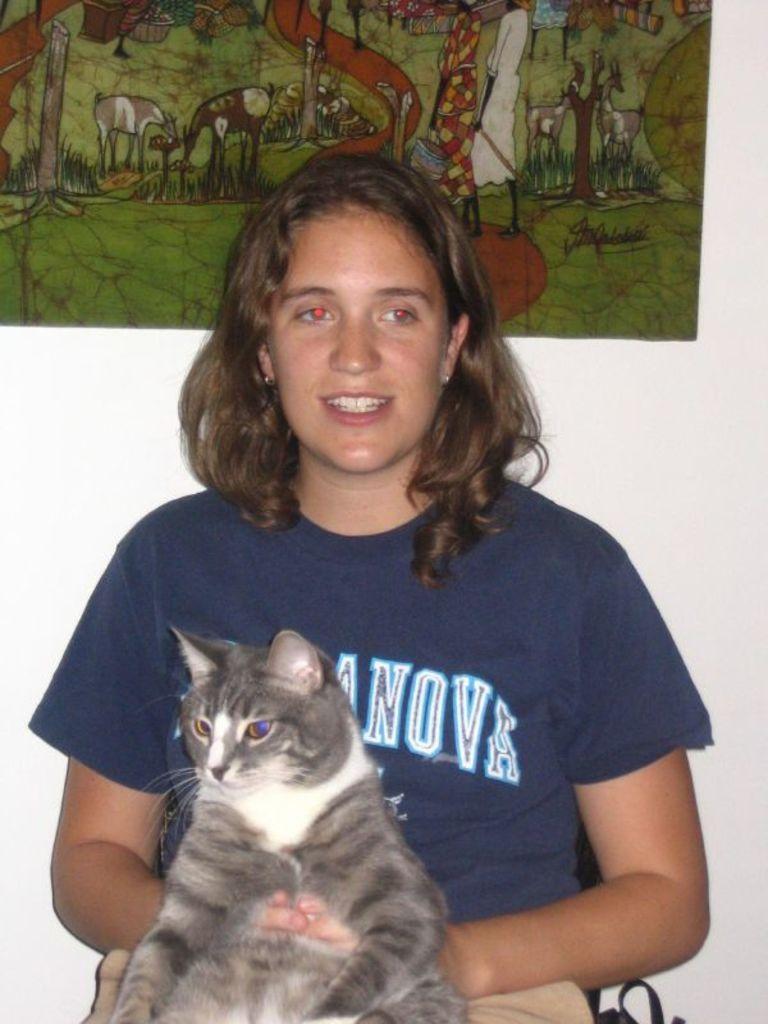Please provide a concise description of this image. In this image i can see a woman sitting and holding a cat in her lap. In the background i can see the wall and a photo. 